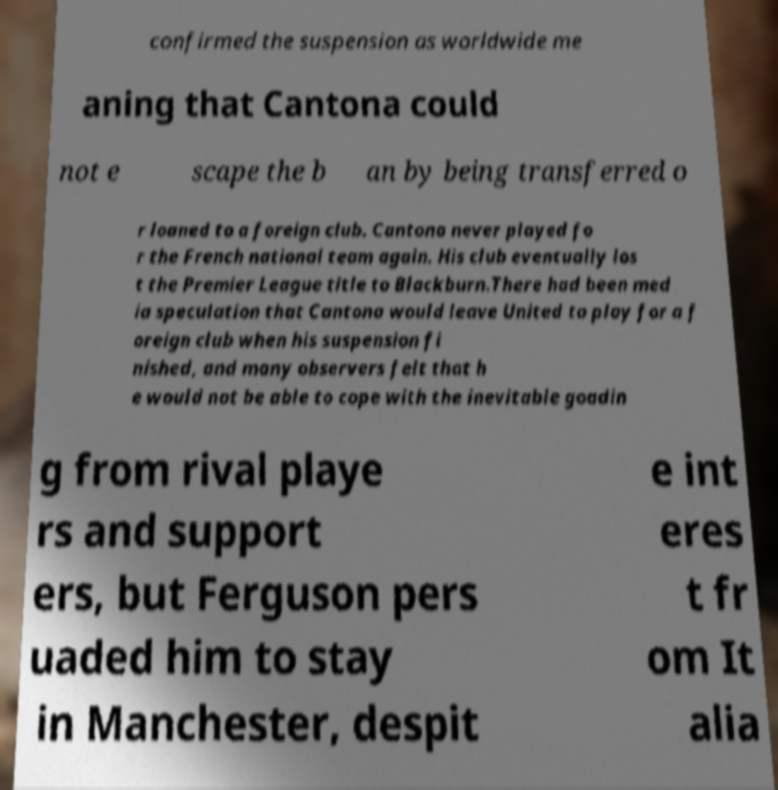Please identify and transcribe the text found in this image. confirmed the suspension as worldwide me aning that Cantona could not e scape the b an by being transferred o r loaned to a foreign club. Cantona never played fo r the French national team again. His club eventually los t the Premier League title to Blackburn.There had been med ia speculation that Cantona would leave United to play for a f oreign club when his suspension fi nished, and many observers felt that h e would not be able to cope with the inevitable goadin g from rival playe rs and support ers, but Ferguson pers uaded him to stay in Manchester, despit e int eres t fr om It alia 